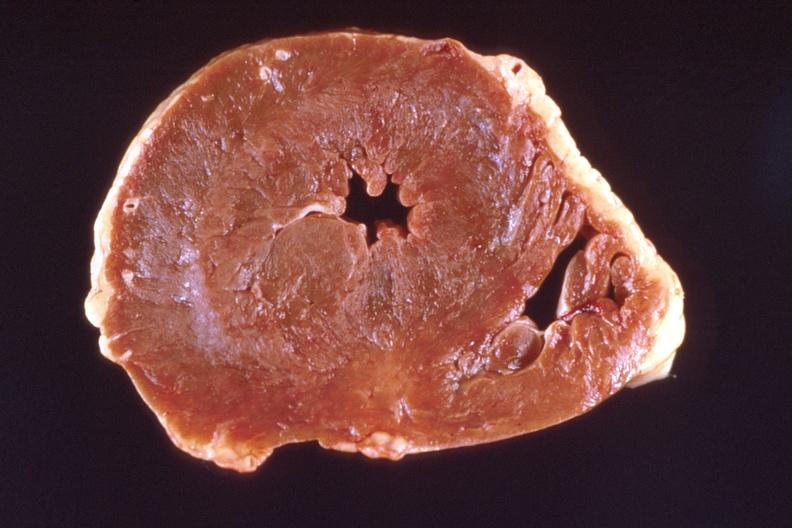how is heart , marked left hypertrophy?
Answer the question using a single word or phrase. Ventricular 